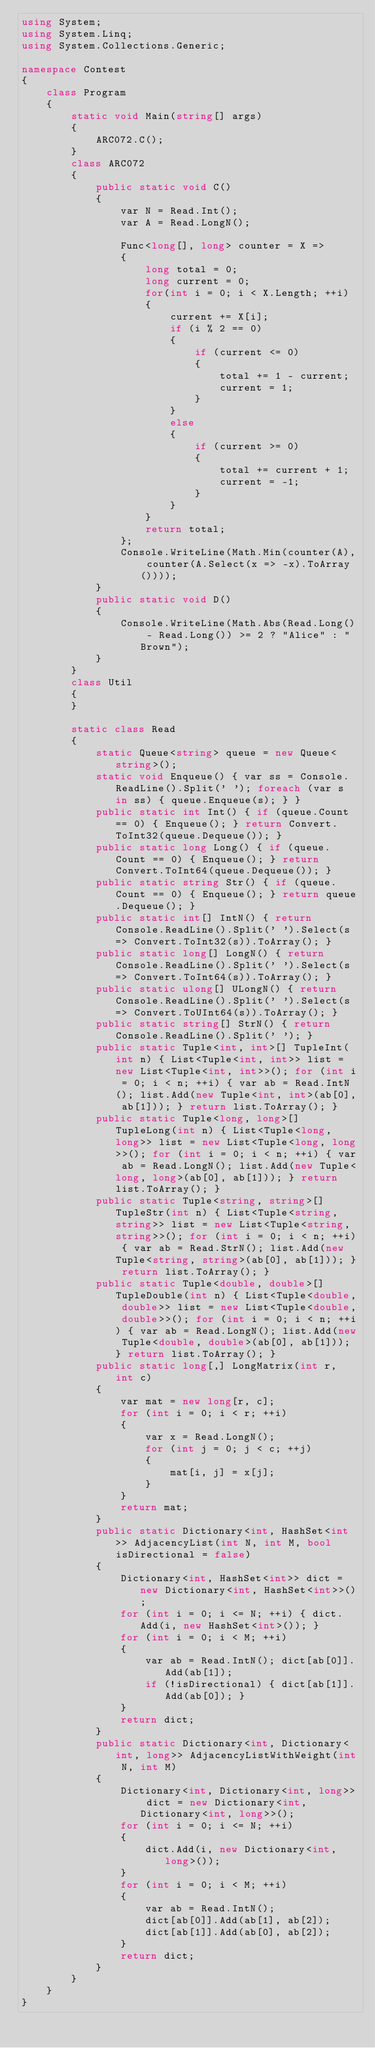<code> <loc_0><loc_0><loc_500><loc_500><_C#_>using System;
using System.Linq;
using System.Collections.Generic;

namespace Contest
{
    class Program
    {
        static void Main(string[] args)
        {
            ARC072.C();
        }
        class ARC072
        {
            public static void C()
            {
                var N = Read.Int();
                var A = Read.LongN();

                Func<long[], long> counter = X =>
                {
                    long total = 0;
                    long current = 0;
                    for(int i = 0; i < X.Length; ++i)
                    {
                        current += X[i];
                        if (i % 2 == 0)
                        {
                            if (current <= 0)
                            {
                                total += 1 - current;
                                current = 1;
                            }
                        }
                        else
                        {
                            if (current >= 0)
                            {
                                total += current + 1;
                                current = -1;
                            }
                        }
                    }
                    return total;
                };
                Console.WriteLine(Math.Min(counter(A), counter(A.Select(x => -x).ToArray())));
            }
            public static void D()
            {
                Console.WriteLine(Math.Abs(Read.Long() - Read.Long()) >= 2 ? "Alice" : "Brown");
            }
        }
        class Util
        {
        }

        static class Read
        {
            static Queue<string> queue = new Queue<string>();
            static void Enqueue() { var ss = Console.ReadLine().Split(' '); foreach (var s in ss) { queue.Enqueue(s); } }
            public static int Int() { if (queue.Count == 0) { Enqueue(); } return Convert.ToInt32(queue.Dequeue()); }
            public static long Long() { if (queue.Count == 0) { Enqueue(); } return Convert.ToInt64(queue.Dequeue()); }
            public static string Str() { if (queue.Count == 0) { Enqueue(); } return queue.Dequeue(); }
            public static int[] IntN() { return Console.ReadLine().Split(' ').Select(s => Convert.ToInt32(s)).ToArray(); }
            public static long[] LongN() { return Console.ReadLine().Split(' ').Select(s => Convert.ToInt64(s)).ToArray(); }
            public static ulong[] ULongN() { return Console.ReadLine().Split(' ').Select(s => Convert.ToUInt64(s)).ToArray(); }
            public static string[] StrN() { return Console.ReadLine().Split(' '); }
            public static Tuple<int, int>[] TupleInt(int n) { List<Tuple<int, int>> list = new List<Tuple<int, int>>(); for (int i = 0; i < n; ++i) { var ab = Read.IntN(); list.Add(new Tuple<int, int>(ab[0], ab[1])); } return list.ToArray(); }
            public static Tuple<long, long>[] TupleLong(int n) { List<Tuple<long, long>> list = new List<Tuple<long, long>>(); for (int i = 0; i < n; ++i) { var ab = Read.LongN(); list.Add(new Tuple<long, long>(ab[0], ab[1])); } return list.ToArray(); }
            public static Tuple<string, string>[] TupleStr(int n) { List<Tuple<string, string>> list = new List<Tuple<string, string>>(); for (int i = 0; i < n; ++i) { var ab = Read.StrN(); list.Add(new Tuple<string, string>(ab[0], ab[1])); } return list.ToArray(); }
            public static Tuple<double, double>[] TupleDouble(int n) { List<Tuple<double, double>> list = new List<Tuple<double, double>>(); for (int i = 0; i < n; ++i) { var ab = Read.LongN(); list.Add(new Tuple<double, double>(ab[0], ab[1])); } return list.ToArray(); }
            public static long[,] LongMatrix(int r, int c)
            {
                var mat = new long[r, c];
                for (int i = 0; i < r; ++i)
                {
                    var x = Read.LongN();
                    for (int j = 0; j < c; ++j)
                    {
                        mat[i, j] = x[j];
                    }
                }
                return mat;
            }
            public static Dictionary<int, HashSet<int>> AdjacencyList(int N, int M, bool isDirectional = false)
            {
                Dictionary<int, HashSet<int>> dict = new Dictionary<int, HashSet<int>>();
                for (int i = 0; i <= N; ++i) { dict.Add(i, new HashSet<int>()); }
                for (int i = 0; i < M; ++i)
                {
                    var ab = Read.IntN(); dict[ab[0]].Add(ab[1]);
                    if (!isDirectional) { dict[ab[1]].Add(ab[0]); }
                }
                return dict;
            }
            public static Dictionary<int, Dictionary<int, long>> AdjacencyListWithWeight(int N, int M)
            {
                Dictionary<int, Dictionary<int, long>> dict = new Dictionary<int, Dictionary<int, long>>();
                for (int i = 0; i <= N; ++i)
                {
                    dict.Add(i, new Dictionary<int, long>());
                }
                for (int i = 0; i < M; ++i)
                {
                    var ab = Read.IntN();
                    dict[ab[0]].Add(ab[1], ab[2]);
                    dict[ab[1]].Add(ab[0], ab[2]);
                }
                return dict;
            }
        }
    }
}
</code> 